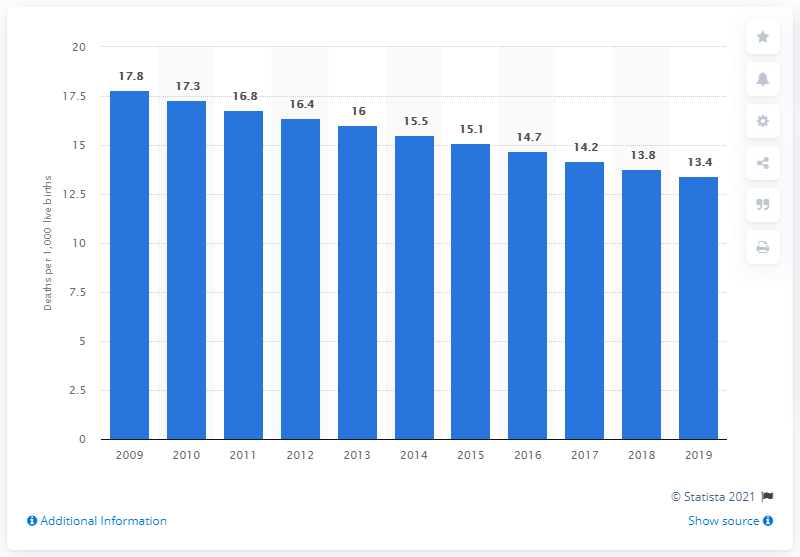Highlight a few significant elements in this photo. In 2019, the infant mortality rate in Jordan was 13.4 deaths per 1,000 live births, indicating a relatively high rate of deaths among infants in the country. 